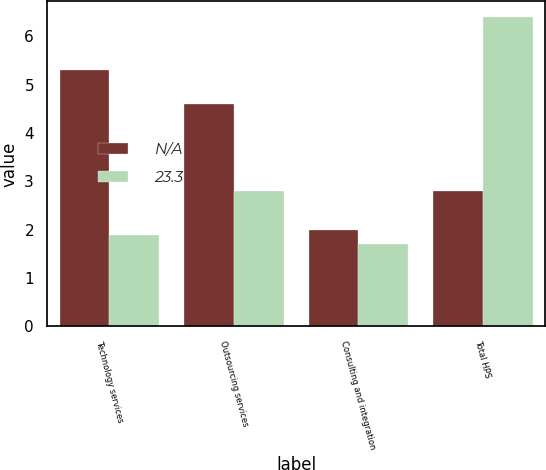<chart> <loc_0><loc_0><loc_500><loc_500><stacked_bar_chart><ecel><fcel>Technology services<fcel>Outsourcing services<fcel>Consulting and integration<fcel>Total HPS<nl><fcel>nan<fcel>5.3<fcel>4.6<fcel>2<fcel>2.8<nl><fcel>23.3<fcel>1.9<fcel>2.8<fcel>1.7<fcel>6.4<nl></chart> 